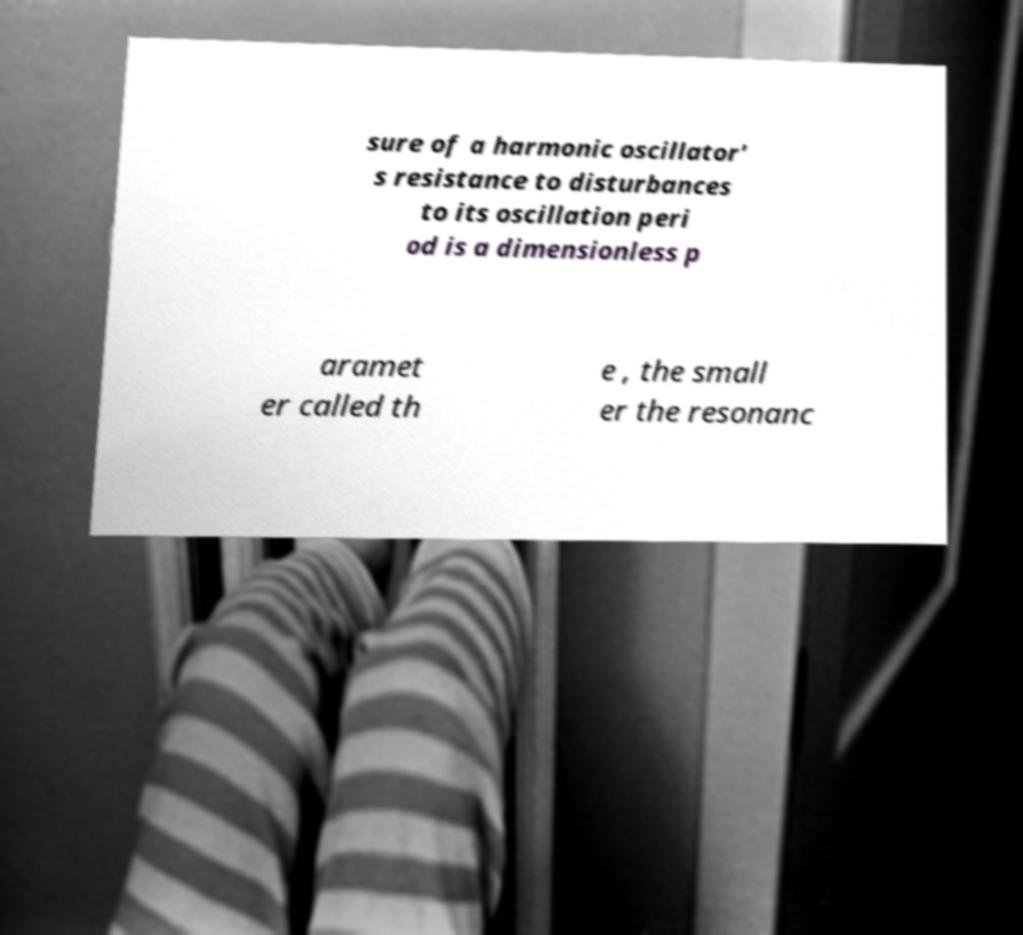What messages or text are displayed in this image? I need them in a readable, typed format. sure of a harmonic oscillator' s resistance to disturbances to its oscillation peri od is a dimensionless p aramet er called th e , the small er the resonanc 